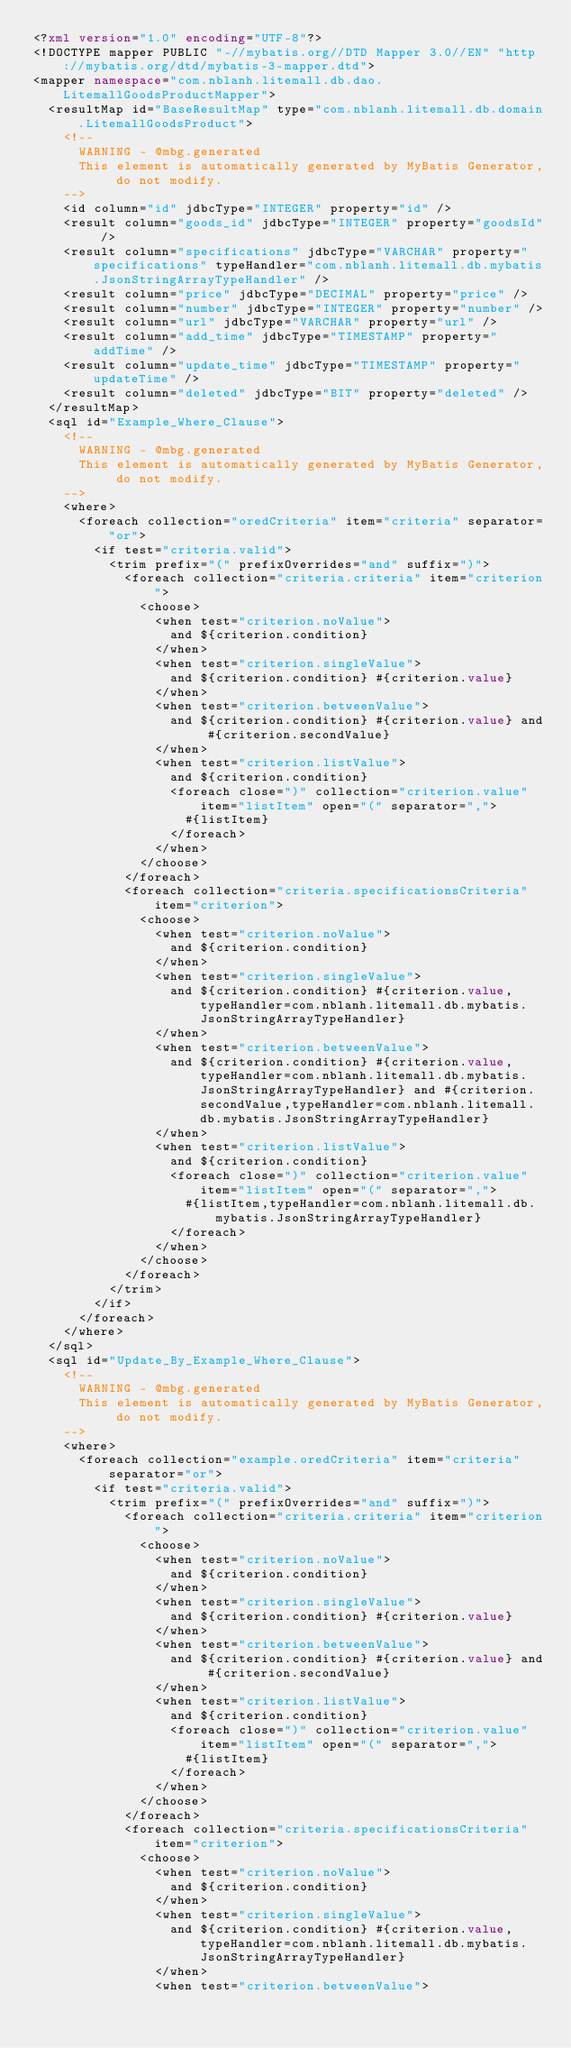<code> <loc_0><loc_0><loc_500><loc_500><_XML_><?xml version="1.0" encoding="UTF-8"?>
<!DOCTYPE mapper PUBLIC "-//mybatis.org//DTD Mapper 3.0//EN" "http://mybatis.org/dtd/mybatis-3-mapper.dtd">
<mapper namespace="com.nblanh.litemall.db.dao.LitemallGoodsProductMapper">
  <resultMap id="BaseResultMap" type="com.nblanh.litemall.db.domain.LitemallGoodsProduct">
    <!--
      WARNING - @mbg.generated
      This element is automatically generated by MyBatis Generator, do not modify.
    -->
    <id column="id" jdbcType="INTEGER" property="id" />
    <result column="goods_id" jdbcType="INTEGER" property="goodsId" />
    <result column="specifications" jdbcType="VARCHAR" property="specifications" typeHandler="com.nblanh.litemall.db.mybatis.JsonStringArrayTypeHandler" />
    <result column="price" jdbcType="DECIMAL" property="price" />
    <result column="number" jdbcType="INTEGER" property="number" />
    <result column="url" jdbcType="VARCHAR" property="url" />
    <result column="add_time" jdbcType="TIMESTAMP" property="addTime" />
    <result column="update_time" jdbcType="TIMESTAMP" property="updateTime" />
    <result column="deleted" jdbcType="BIT" property="deleted" />
  </resultMap>
  <sql id="Example_Where_Clause">
    <!--
      WARNING - @mbg.generated
      This element is automatically generated by MyBatis Generator, do not modify.
    -->
    <where>
      <foreach collection="oredCriteria" item="criteria" separator="or">
        <if test="criteria.valid">
          <trim prefix="(" prefixOverrides="and" suffix=")">
            <foreach collection="criteria.criteria" item="criterion">
              <choose>
                <when test="criterion.noValue">
                  and ${criterion.condition}
                </when>
                <when test="criterion.singleValue">
                  and ${criterion.condition} #{criterion.value}
                </when>
                <when test="criterion.betweenValue">
                  and ${criterion.condition} #{criterion.value} and #{criterion.secondValue}
                </when>
                <when test="criterion.listValue">
                  and ${criterion.condition}
                  <foreach close=")" collection="criterion.value" item="listItem" open="(" separator=",">
                    #{listItem}
                  </foreach>
                </when>
              </choose>
            </foreach>
            <foreach collection="criteria.specificationsCriteria" item="criterion">
              <choose>
                <when test="criterion.noValue">
                  and ${criterion.condition}
                </when>
                <when test="criterion.singleValue">
                  and ${criterion.condition} #{criterion.value,typeHandler=com.nblanh.litemall.db.mybatis.JsonStringArrayTypeHandler}
                </when>
                <when test="criterion.betweenValue">
                  and ${criterion.condition} #{criterion.value,typeHandler=com.nblanh.litemall.db.mybatis.JsonStringArrayTypeHandler} and #{criterion.secondValue,typeHandler=com.nblanh.litemall.db.mybatis.JsonStringArrayTypeHandler}
                </when>
                <when test="criterion.listValue">
                  and ${criterion.condition}
                  <foreach close=")" collection="criterion.value" item="listItem" open="(" separator=",">
                    #{listItem,typeHandler=com.nblanh.litemall.db.mybatis.JsonStringArrayTypeHandler}
                  </foreach>
                </when>
              </choose>
            </foreach>
          </trim>
        </if>
      </foreach>
    </where>
  </sql>
  <sql id="Update_By_Example_Where_Clause">
    <!--
      WARNING - @mbg.generated
      This element is automatically generated by MyBatis Generator, do not modify.
    -->
    <where>
      <foreach collection="example.oredCriteria" item="criteria" separator="or">
        <if test="criteria.valid">
          <trim prefix="(" prefixOverrides="and" suffix=")">
            <foreach collection="criteria.criteria" item="criterion">
              <choose>
                <when test="criterion.noValue">
                  and ${criterion.condition}
                </when>
                <when test="criterion.singleValue">
                  and ${criterion.condition} #{criterion.value}
                </when>
                <when test="criterion.betweenValue">
                  and ${criterion.condition} #{criterion.value} and #{criterion.secondValue}
                </when>
                <when test="criterion.listValue">
                  and ${criterion.condition}
                  <foreach close=")" collection="criterion.value" item="listItem" open="(" separator=",">
                    #{listItem}
                  </foreach>
                </when>
              </choose>
            </foreach>
            <foreach collection="criteria.specificationsCriteria" item="criterion">
              <choose>
                <when test="criterion.noValue">
                  and ${criterion.condition}
                </when>
                <when test="criterion.singleValue">
                  and ${criterion.condition} #{criterion.value,typeHandler=com.nblanh.litemall.db.mybatis.JsonStringArrayTypeHandler}
                </when>
                <when test="criterion.betweenValue"></code> 